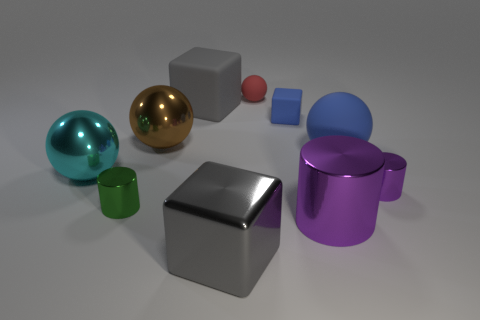Subtract all cylinders. How many objects are left? 7 Subtract all large metallic things. Subtract all tiny metal cylinders. How many objects are left? 4 Add 5 tiny blue matte objects. How many tiny blue matte objects are left? 6 Add 6 big red metallic balls. How many big red metallic balls exist? 6 Subtract 0 gray cylinders. How many objects are left? 10 